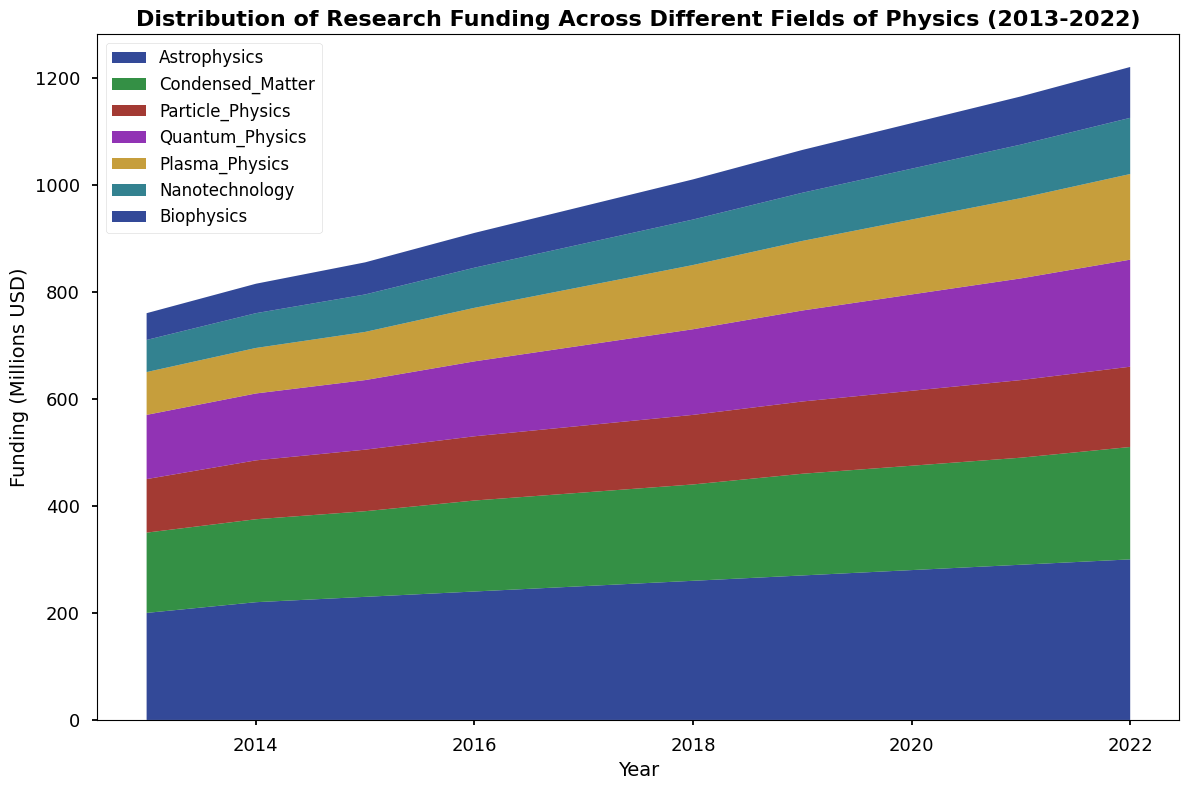What is the total funding for Astrophysics and Nanotechnology in 2018? First, locate the funding for both Astrophysics and Nanotechnology in 2018. Astrophysics has 260 million USD and Nanotechnology has 85 million USD. Adding these amounts: 260 + 85 = 345 million USD.
Answer: 345 million USD Which field had the largest increase in funding from 2013 to 2022? Calculate the difference in funding for each field by subtracting the 2013 values from the 2022 values. Astrophysics: 300-200 = 100, Condensed Matter: 210-150 = 60, Particle Physics: 150-100 = 50, Quantum Physics: 200-120 = 80, Plasma Physics: 160-80 = 80, Nanotechnology: 105-60 = 45, Biophysics: 95-50 = 45. Astrophysics has the largest increase of 100 million USD.
Answer: Astrophysics How much more funding was allocated to Plasma Physics than Biophysics in 2019? In 2019, Plasma Physics received 130 million USD, and Biophysics received 80 million USD. The difference is 130 - 80 = 50 million USD.
Answer: 50 million USD Which field had the most consistent increase in funding across the decade? By observing the steady increments in the lines, Astrophysics consistently increased from 200 (2013) to 300 (2022) in regular yearly increments of 10 million USD.
Answer: Astrophysics Was Quantum Physics or Particle Physics funded more in the first half of the decade (2013-2017)? Sum the funding for both fields from 2013 to 2017. Quantum Physics: 120+125+130+140+150 = 665, Particle Physics: 100+110+115+120+125 = 570. Quantum Physics received more funding in this period.
Answer: Quantum Physics Compare the funding for Nanotechnology and Biophysics in 2022. Which received more? In 2022, Nanotechnology received 105 million USD, and Biophysics received 95 million USD. Nanotechnology received more funding.
Answer: Nanotechnology What is the average funding for Condensed Matter over the decade? Sum the funding for Condensed Matter from 2013 to 2022: 150+155+160+170+175+180+190+195+200+210 = 1785. Divide by 10 to find the average: 1785 / 10 = 178.5 million USD.
Answer: 178.5 million USD Which field showed a clear linear growth trend? Observing the chart, Astrophysics shows a clear, linear upward trend from 200 million USD in 2013 to 300 million USD in 2022.
Answer: Astrophysics 